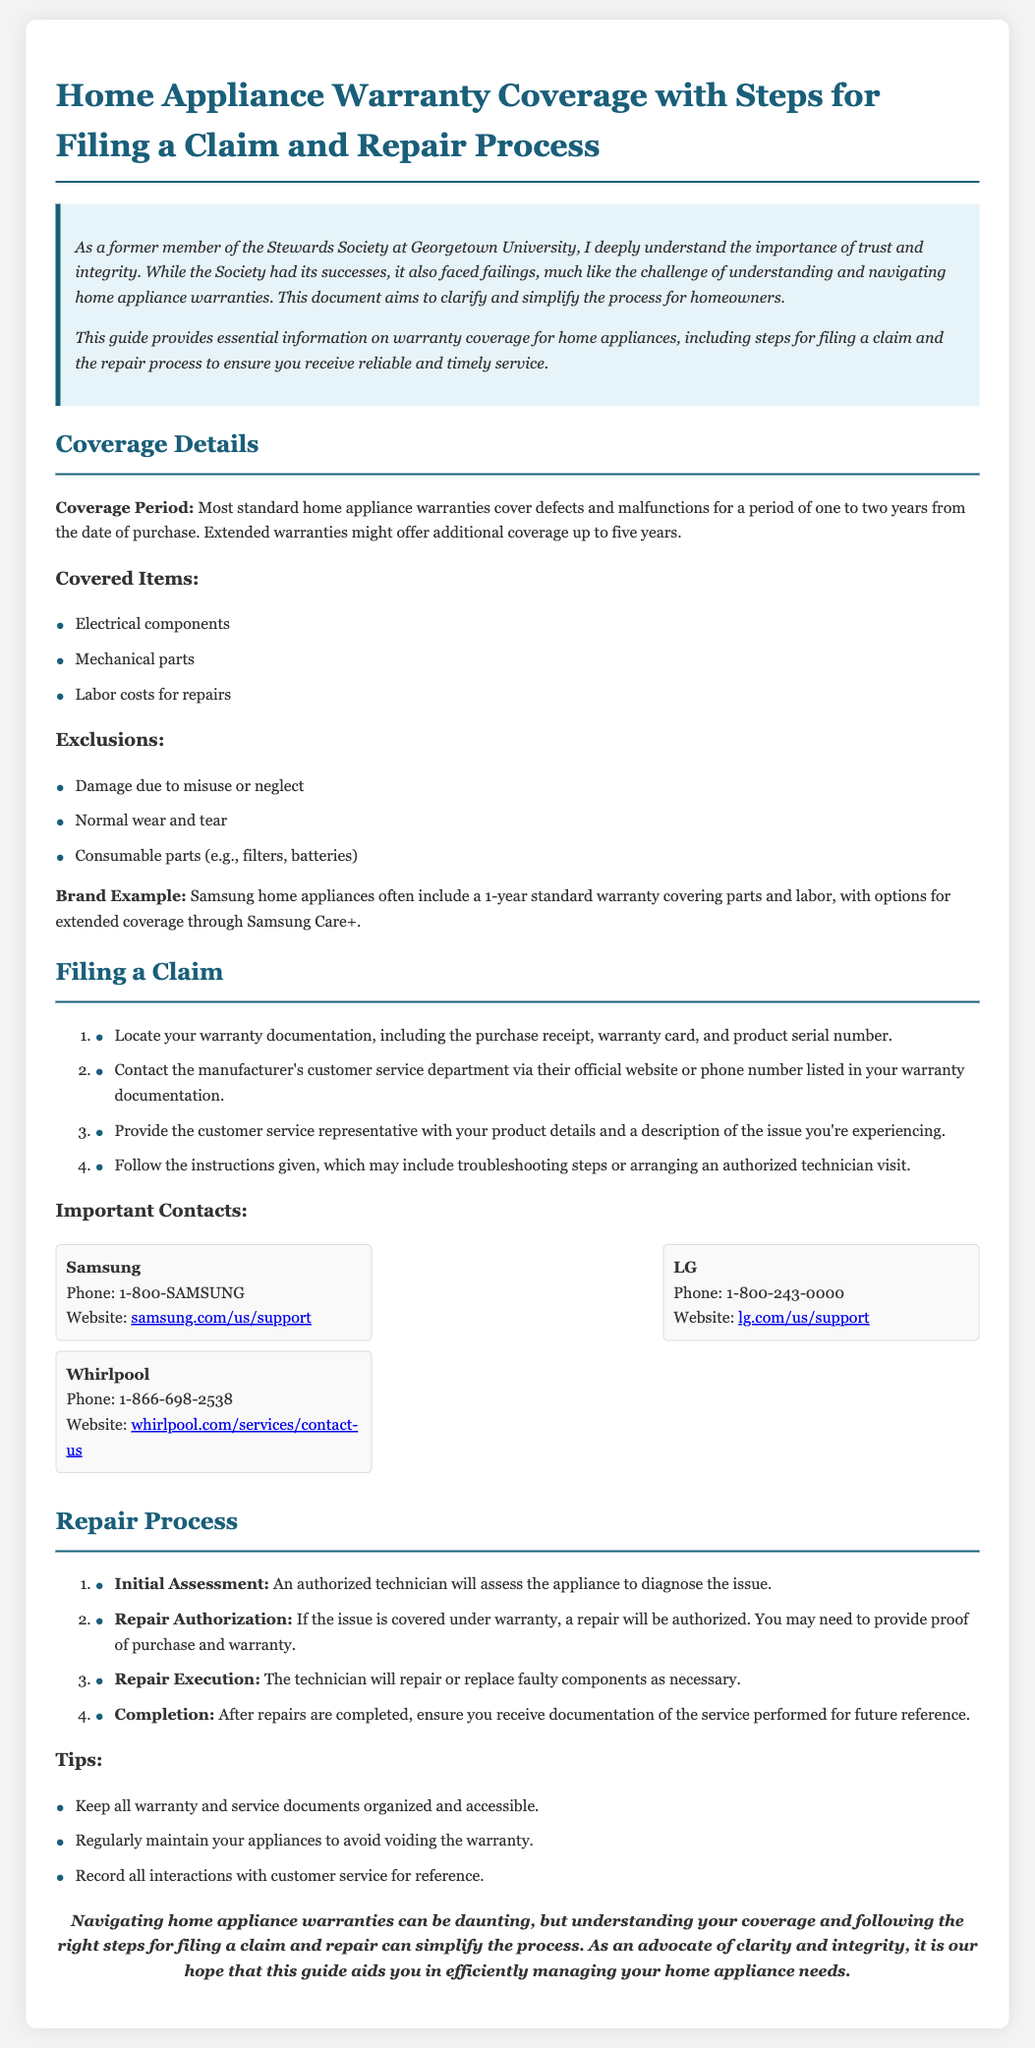What is the coverage period for most standard home appliance warranties? The coverage period is for a period of one to two years from the date of purchase.
Answer: one to two years Which components are covered under standard warranties? The covered items include electrical components, mechanical parts, and labor costs for repairs.
Answer: electrical components, mechanical parts, labor costs What should you locate before filing a claim? Before filing a claim, you should locate warranty documentation, including the purchase receipt, warranty card, and product serial number.
Answer: warranty documentation, purchase receipt, warranty card, product serial number What is the first step in the repair process? The first step is initial assessment by an authorized technician to diagnose the issue.
Answer: initial assessment What are the exclusions in the warranty coverage? Exclusions include damage due to misuse or neglect, normal wear and tear, and consumable parts.
Answer: damage due to misuse or neglect, normal wear and tear, consumable parts Which brand mentioned offers a 1-year standard warranty? The brand mentioned that offers a 1-year standard warranty is Samsung.
Answer: Samsung What is the phone number for LG customer service? The phone number for LG customer service is 1-800-243-0000.
Answer: 1-800-243-0000 What should you keep organized to avoid difficulties with your warranty? You should keep all warranty and service documents organized and accessible.
Answer: warranty and service documents What is the purpose of the document? The purpose of the document is to clarify and simplify the process for homeowners regarding home appliance warranties.
Answer: clarify and simplify the process 